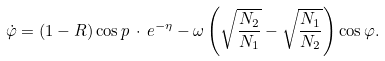Convert formula to latex. <formula><loc_0><loc_0><loc_500><loc_500>\dot { \varphi } = \left ( 1 - R \right ) \cos { p } \, \cdot \, e ^ { - \eta } - \omega \left ( \sqrt { \frac { N _ { 2 } } { N _ { 1 } } } - \sqrt { \frac { N _ { 1 } } { N _ { 2 } } } \right ) \cos { \varphi } .</formula> 